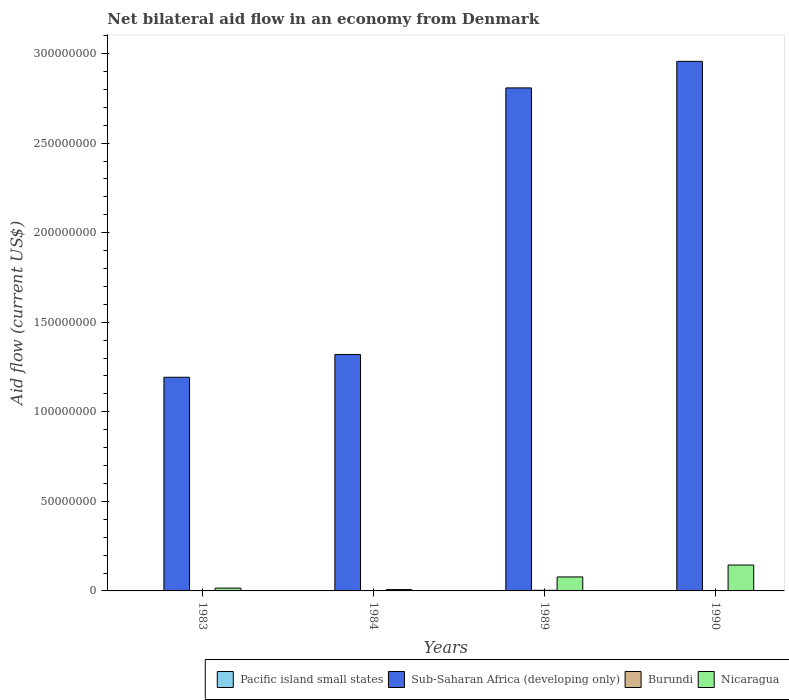How many different coloured bars are there?
Give a very brief answer. 4. How many groups of bars are there?
Offer a very short reply. 4. Are the number of bars per tick equal to the number of legend labels?
Ensure brevity in your answer.  Yes. How many bars are there on the 2nd tick from the left?
Make the answer very short. 4. How many bars are there on the 2nd tick from the right?
Provide a succinct answer. 4. In how many cases, is the number of bars for a given year not equal to the number of legend labels?
Your answer should be very brief. 0. What is the net bilateral aid flow in Pacific island small states in 1983?
Provide a short and direct response. 1.30e+05. Across all years, what is the maximum net bilateral aid flow in Burundi?
Provide a succinct answer. 3.40e+05. Across all years, what is the minimum net bilateral aid flow in Nicaragua?
Provide a short and direct response. 7.50e+05. In which year was the net bilateral aid flow in Pacific island small states maximum?
Your answer should be very brief. 1983. What is the total net bilateral aid flow in Burundi in the graph?
Offer a terse response. 4.80e+05. What is the difference between the net bilateral aid flow in Burundi in 1990 and the net bilateral aid flow in Nicaragua in 1984?
Make the answer very short. -7.20e+05. What is the average net bilateral aid flow in Pacific island small states per year?
Provide a short and direct response. 6.50e+04. In the year 1990, what is the difference between the net bilateral aid flow in Burundi and net bilateral aid flow in Nicaragua?
Offer a terse response. -1.44e+07. What is the ratio of the net bilateral aid flow in Burundi in 1983 to that in 1989?
Keep it short and to the point. 0.18. Is the net bilateral aid flow in Burundi in 1989 less than that in 1990?
Give a very brief answer. No. What is the difference between the highest and the second highest net bilateral aid flow in Sub-Saharan Africa (developing only)?
Your answer should be very brief. 1.48e+07. Is the sum of the net bilateral aid flow in Nicaragua in 1983 and 1989 greater than the maximum net bilateral aid flow in Pacific island small states across all years?
Ensure brevity in your answer.  Yes. What does the 4th bar from the left in 1983 represents?
Your answer should be compact. Nicaragua. What does the 2nd bar from the right in 1990 represents?
Your response must be concise. Burundi. Is it the case that in every year, the sum of the net bilateral aid flow in Burundi and net bilateral aid flow in Pacific island small states is greater than the net bilateral aid flow in Sub-Saharan Africa (developing only)?
Make the answer very short. No. Are all the bars in the graph horizontal?
Offer a very short reply. No. Does the graph contain any zero values?
Make the answer very short. No. Where does the legend appear in the graph?
Your response must be concise. Bottom right. How many legend labels are there?
Keep it short and to the point. 4. How are the legend labels stacked?
Provide a short and direct response. Horizontal. What is the title of the graph?
Ensure brevity in your answer.  Net bilateral aid flow in an economy from Denmark. What is the label or title of the X-axis?
Make the answer very short. Years. What is the Aid flow (current US$) in Sub-Saharan Africa (developing only) in 1983?
Your answer should be compact. 1.19e+08. What is the Aid flow (current US$) of Nicaragua in 1983?
Your answer should be very brief. 1.57e+06. What is the Aid flow (current US$) in Sub-Saharan Africa (developing only) in 1984?
Ensure brevity in your answer.  1.32e+08. What is the Aid flow (current US$) in Nicaragua in 1984?
Provide a short and direct response. 7.50e+05. What is the Aid flow (current US$) of Sub-Saharan Africa (developing only) in 1989?
Ensure brevity in your answer.  2.81e+08. What is the Aid flow (current US$) of Burundi in 1989?
Offer a terse response. 3.40e+05. What is the Aid flow (current US$) of Nicaragua in 1989?
Offer a terse response. 7.81e+06. What is the Aid flow (current US$) in Pacific island small states in 1990?
Offer a very short reply. 4.00e+04. What is the Aid flow (current US$) of Sub-Saharan Africa (developing only) in 1990?
Provide a succinct answer. 2.96e+08. What is the Aid flow (current US$) in Burundi in 1990?
Provide a short and direct response. 3.00e+04. What is the Aid flow (current US$) in Nicaragua in 1990?
Offer a very short reply. 1.45e+07. Across all years, what is the maximum Aid flow (current US$) in Sub-Saharan Africa (developing only)?
Keep it short and to the point. 2.96e+08. Across all years, what is the maximum Aid flow (current US$) of Nicaragua?
Your response must be concise. 1.45e+07. Across all years, what is the minimum Aid flow (current US$) in Sub-Saharan Africa (developing only)?
Your answer should be very brief. 1.19e+08. Across all years, what is the minimum Aid flow (current US$) in Burundi?
Your response must be concise. 3.00e+04. Across all years, what is the minimum Aid flow (current US$) in Nicaragua?
Make the answer very short. 7.50e+05. What is the total Aid flow (current US$) in Pacific island small states in the graph?
Your response must be concise. 2.60e+05. What is the total Aid flow (current US$) of Sub-Saharan Africa (developing only) in the graph?
Provide a succinct answer. 8.28e+08. What is the total Aid flow (current US$) of Nicaragua in the graph?
Offer a very short reply. 2.46e+07. What is the difference between the Aid flow (current US$) of Sub-Saharan Africa (developing only) in 1983 and that in 1984?
Make the answer very short. -1.27e+07. What is the difference between the Aid flow (current US$) in Burundi in 1983 and that in 1984?
Keep it short and to the point. 10000. What is the difference between the Aid flow (current US$) of Nicaragua in 1983 and that in 1984?
Ensure brevity in your answer.  8.20e+05. What is the difference between the Aid flow (current US$) of Sub-Saharan Africa (developing only) in 1983 and that in 1989?
Your response must be concise. -1.62e+08. What is the difference between the Aid flow (current US$) of Burundi in 1983 and that in 1989?
Offer a very short reply. -2.80e+05. What is the difference between the Aid flow (current US$) of Nicaragua in 1983 and that in 1989?
Offer a very short reply. -6.24e+06. What is the difference between the Aid flow (current US$) in Pacific island small states in 1983 and that in 1990?
Ensure brevity in your answer.  9.00e+04. What is the difference between the Aid flow (current US$) of Sub-Saharan Africa (developing only) in 1983 and that in 1990?
Your response must be concise. -1.76e+08. What is the difference between the Aid flow (current US$) of Nicaragua in 1983 and that in 1990?
Make the answer very short. -1.29e+07. What is the difference between the Aid flow (current US$) in Pacific island small states in 1984 and that in 1989?
Make the answer very short. 10000. What is the difference between the Aid flow (current US$) of Sub-Saharan Africa (developing only) in 1984 and that in 1989?
Offer a very short reply. -1.49e+08. What is the difference between the Aid flow (current US$) in Nicaragua in 1984 and that in 1989?
Provide a succinct answer. -7.06e+06. What is the difference between the Aid flow (current US$) of Pacific island small states in 1984 and that in 1990?
Make the answer very short. 10000. What is the difference between the Aid flow (current US$) of Sub-Saharan Africa (developing only) in 1984 and that in 1990?
Your response must be concise. -1.64e+08. What is the difference between the Aid flow (current US$) in Nicaragua in 1984 and that in 1990?
Ensure brevity in your answer.  -1.37e+07. What is the difference between the Aid flow (current US$) of Sub-Saharan Africa (developing only) in 1989 and that in 1990?
Your answer should be very brief. -1.48e+07. What is the difference between the Aid flow (current US$) in Burundi in 1989 and that in 1990?
Offer a terse response. 3.10e+05. What is the difference between the Aid flow (current US$) of Nicaragua in 1989 and that in 1990?
Ensure brevity in your answer.  -6.65e+06. What is the difference between the Aid flow (current US$) in Pacific island small states in 1983 and the Aid flow (current US$) in Sub-Saharan Africa (developing only) in 1984?
Keep it short and to the point. -1.32e+08. What is the difference between the Aid flow (current US$) of Pacific island small states in 1983 and the Aid flow (current US$) of Nicaragua in 1984?
Ensure brevity in your answer.  -6.20e+05. What is the difference between the Aid flow (current US$) in Sub-Saharan Africa (developing only) in 1983 and the Aid flow (current US$) in Burundi in 1984?
Your answer should be compact. 1.19e+08. What is the difference between the Aid flow (current US$) of Sub-Saharan Africa (developing only) in 1983 and the Aid flow (current US$) of Nicaragua in 1984?
Give a very brief answer. 1.19e+08. What is the difference between the Aid flow (current US$) in Burundi in 1983 and the Aid flow (current US$) in Nicaragua in 1984?
Ensure brevity in your answer.  -6.90e+05. What is the difference between the Aid flow (current US$) in Pacific island small states in 1983 and the Aid flow (current US$) in Sub-Saharan Africa (developing only) in 1989?
Your answer should be very brief. -2.81e+08. What is the difference between the Aid flow (current US$) of Pacific island small states in 1983 and the Aid flow (current US$) of Burundi in 1989?
Your response must be concise. -2.10e+05. What is the difference between the Aid flow (current US$) of Pacific island small states in 1983 and the Aid flow (current US$) of Nicaragua in 1989?
Ensure brevity in your answer.  -7.68e+06. What is the difference between the Aid flow (current US$) of Sub-Saharan Africa (developing only) in 1983 and the Aid flow (current US$) of Burundi in 1989?
Your answer should be very brief. 1.19e+08. What is the difference between the Aid flow (current US$) in Sub-Saharan Africa (developing only) in 1983 and the Aid flow (current US$) in Nicaragua in 1989?
Offer a terse response. 1.11e+08. What is the difference between the Aid flow (current US$) of Burundi in 1983 and the Aid flow (current US$) of Nicaragua in 1989?
Give a very brief answer. -7.75e+06. What is the difference between the Aid flow (current US$) of Pacific island small states in 1983 and the Aid flow (current US$) of Sub-Saharan Africa (developing only) in 1990?
Your response must be concise. -2.96e+08. What is the difference between the Aid flow (current US$) of Pacific island small states in 1983 and the Aid flow (current US$) of Burundi in 1990?
Give a very brief answer. 1.00e+05. What is the difference between the Aid flow (current US$) in Pacific island small states in 1983 and the Aid flow (current US$) in Nicaragua in 1990?
Offer a very short reply. -1.43e+07. What is the difference between the Aid flow (current US$) in Sub-Saharan Africa (developing only) in 1983 and the Aid flow (current US$) in Burundi in 1990?
Your answer should be compact. 1.19e+08. What is the difference between the Aid flow (current US$) of Sub-Saharan Africa (developing only) in 1983 and the Aid flow (current US$) of Nicaragua in 1990?
Provide a succinct answer. 1.05e+08. What is the difference between the Aid flow (current US$) in Burundi in 1983 and the Aid flow (current US$) in Nicaragua in 1990?
Provide a succinct answer. -1.44e+07. What is the difference between the Aid flow (current US$) in Pacific island small states in 1984 and the Aid flow (current US$) in Sub-Saharan Africa (developing only) in 1989?
Your answer should be very brief. -2.81e+08. What is the difference between the Aid flow (current US$) of Pacific island small states in 1984 and the Aid flow (current US$) of Burundi in 1989?
Ensure brevity in your answer.  -2.90e+05. What is the difference between the Aid flow (current US$) of Pacific island small states in 1984 and the Aid flow (current US$) of Nicaragua in 1989?
Your response must be concise. -7.76e+06. What is the difference between the Aid flow (current US$) of Sub-Saharan Africa (developing only) in 1984 and the Aid flow (current US$) of Burundi in 1989?
Ensure brevity in your answer.  1.32e+08. What is the difference between the Aid flow (current US$) of Sub-Saharan Africa (developing only) in 1984 and the Aid flow (current US$) of Nicaragua in 1989?
Give a very brief answer. 1.24e+08. What is the difference between the Aid flow (current US$) of Burundi in 1984 and the Aid flow (current US$) of Nicaragua in 1989?
Offer a very short reply. -7.76e+06. What is the difference between the Aid flow (current US$) of Pacific island small states in 1984 and the Aid flow (current US$) of Sub-Saharan Africa (developing only) in 1990?
Your response must be concise. -2.96e+08. What is the difference between the Aid flow (current US$) in Pacific island small states in 1984 and the Aid flow (current US$) in Burundi in 1990?
Ensure brevity in your answer.  2.00e+04. What is the difference between the Aid flow (current US$) in Pacific island small states in 1984 and the Aid flow (current US$) in Nicaragua in 1990?
Make the answer very short. -1.44e+07. What is the difference between the Aid flow (current US$) of Sub-Saharan Africa (developing only) in 1984 and the Aid flow (current US$) of Burundi in 1990?
Offer a terse response. 1.32e+08. What is the difference between the Aid flow (current US$) in Sub-Saharan Africa (developing only) in 1984 and the Aid flow (current US$) in Nicaragua in 1990?
Your answer should be very brief. 1.18e+08. What is the difference between the Aid flow (current US$) of Burundi in 1984 and the Aid flow (current US$) of Nicaragua in 1990?
Offer a terse response. -1.44e+07. What is the difference between the Aid flow (current US$) of Pacific island small states in 1989 and the Aid flow (current US$) of Sub-Saharan Africa (developing only) in 1990?
Give a very brief answer. -2.96e+08. What is the difference between the Aid flow (current US$) of Pacific island small states in 1989 and the Aid flow (current US$) of Burundi in 1990?
Offer a terse response. 10000. What is the difference between the Aid flow (current US$) in Pacific island small states in 1989 and the Aid flow (current US$) in Nicaragua in 1990?
Offer a very short reply. -1.44e+07. What is the difference between the Aid flow (current US$) of Sub-Saharan Africa (developing only) in 1989 and the Aid flow (current US$) of Burundi in 1990?
Keep it short and to the point. 2.81e+08. What is the difference between the Aid flow (current US$) of Sub-Saharan Africa (developing only) in 1989 and the Aid flow (current US$) of Nicaragua in 1990?
Offer a terse response. 2.66e+08. What is the difference between the Aid flow (current US$) in Burundi in 1989 and the Aid flow (current US$) in Nicaragua in 1990?
Keep it short and to the point. -1.41e+07. What is the average Aid flow (current US$) in Pacific island small states per year?
Provide a succinct answer. 6.50e+04. What is the average Aid flow (current US$) in Sub-Saharan Africa (developing only) per year?
Your response must be concise. 2.07e+08. What is the average Aid flow (current US$) of Burundi per year?
Ensure brevity in your answer.  1.20e+05. What is the average Aid flow (current US$) in Nicaragua per year?
Offer a terse response. 6.15e+06. In the year 1983, what is the difference between the Aid flow (current US$) in Pacific island small states and Aid flow (current US$) in Sub-Saharan Africa (developing only)?
Give a very brief answer. -1.19e+08. In the year 1983, what is the difference between the Aid flow (current US$) of Pacific island small states and Aid flow (current US$) of Burundi?
Provide a succinct answer. 7.00e+04. In the year 1983, what is the difference between the Aid flow (current US$) of Pacific island small states and Aid flow (current US$) of Nicaragua?
Ensure brevity in your answer.  -1.44e+06. In the year 1983, what is the difference between the Aid flow (current US$) of Sub-Saharan Africa (developing only) and Aid flow (current US$) of Burundi?
Ensure brevity in your answer.  1.19e+08. In the year 1983, what is the difference between the Aid flow (current US$) of Sub-Saharan Africa (developing only) and Aid flow (current US$) of Nicaragua?
Offer a terse response. 1.18e+08. In the year 1983, what is the difference between the Aid flow (current US$) of Burundi and Aid flow (current US$) of Nicaragua?
Your response must be concise. -1.51e+06. In the year 1984, what is the difference between the Aid flow (current US$) of Pacific island small states and Aid flow (current US$) of Sub-Saharan Africa (developing only)?
Your answer should be very brief. -1.32e+08. In the year 1984, what is the difference between the Aid flow (current US$) in Pacific island small states and Aid flow (current US$) in Nicaragua?
Keep it short and to the point. -7.00e+05. In the year 1984, what is the difference between the Aid flow (current US$) of Sub-Saharan Africa (developing only) and Aid flow (current US$) of Burundi?
Your answer should be very brief. 1.32e+08. In the year 1984, what is the difference between the Aid flow (current US$) in Sub-Saharan Africa (developing only) and Aid flow (current US$) in Nicaragua?
Provide a short and direct response. 1.31e+08. In the year 1984, what is the difference between the Aid flow (current US$) of Burundi and Aid flow (current US$) of Nicaragua?
Your answer should be very brief. -7.00e+05. In the year 1989, what is the difference between the Aid flow (current US$) of Pacific island small states and Aid flow (current US$) of Sub-Saharan Africa (developing only)?
Make the answer very short. -2.81e+08. In the year 1989, what is the difference between the Aid flow (current US$) in Pacific island small states and Aid flow (current US$) in Burundi?
Offer a very short reply. -3.00e+05. In the year 1989, what is the difference between the Aid flow (current US$) of Pacific island small states and Aid flow (current US$) of Nicaragua?
Provide a short and direct response. -7.77e+06. In the year 1989, what is the difference between the Aid flow (current US$) of Sub-Saharan Africa (developing only) and Aid flow (current US$) of Burundi?
Your answer should be very brief. 2.81e+08. In the year 1989, what is the difference between the Aid flow (current US$) in Sub-Saharan Africa (developing only) and Aid flow (current US$) in Nicaragua?
Your answer should be very brief. 2.73e+08. In the year 1989, what is the difference between the Aid flow (current US$) in Burundi and Aid flow (current US$) in Nicaragua?
Keep it short and to the point. -7.47e+06. In the year 1990, what is the difference between the Aid flow (current US$) of Pacific island small states and Aid flow (current US$) of Sub-Saharan Africa (developing only)?
Your response must be concise. -2.96e+08. In the year 1990, what is the difference between the Aid flow (current US$) in Pacific island small states and Aid flow (current US$) in Nicaragua?
Make the answer very short. -1.44e+07. In the year 1990, what is the difference between the Aid flow (current US$) of Sub-Saharan Africa (developing only) and Aid flow (current US$) of Burundi?
Offer a terse response. 2.96e+08. In the year 1990, what is the difference between the Aid flow (current US$) in Sub-Saharan Africa (developing only) and Aid flow (current US$) in Nicaragua?
Ensure brevity in your answer.  2.81e+08. In the year 1990, what is the difference between the Aid flow (current US$) of Burundi and Aid flow (current US$) of Nicaragua?
Give a very brief answer. -1.44e+07. What is the ratio of the Aid flow (current US$) in Sub-Saharan Africa (developing only) in 1983 to that in 1984?
Provide a succinct answer. 0.9. What is the ratio of the Aid flow (current US$) in Nicaragua in 1983 to that in 1984?
Your answer should be compact. 2.09. What is the ratio of the Aid flow (current US$) of Pacific island small states in 1983 to that in 1989?
Your answer should be very brief. 3.25. What is the ratio of the Aid flow (current US$) in Sub-Saharan Africa (developing only) in 1983 to that in 1989?
Ensure brevity in your answer.  0.42. What is the ratio of the Aid flow (current US$) of Burundi in 1983 to that in 1989?
Your answer should be compact. 0.18. What is the ratio of the Aid flow (current US$) in Nicaragua in 1983 to that in 1989?
Make the answer very short. 0.2. What is the ratio of the Aid flow (current US$) in Sub-Saharan Africa (developing only) in 1983 to that in 1990?
Your answer should be very brief. 0.4. What is the ratio of the Aid flow (current US$) in Burundi in 1983 to that in 1990?
Offer a very short reply. 2. What is the ratio of the Aid flow (current US$) of Nicaragua in 1983 to that in 1990?
Your answer should be compact. 0.11. What is the ratio of the Aid flow (current US$) in Pacific island small states in 1984 to that in 1989?
Ensure brevity in your answer.  1.25. What is the ratio of the Aid flow (current US$) of Sub-Saharan Africa (developing only) in 1984 to that in 1989?
Give a very brief answer. 0.47. What is the ratio of the Aid flow (current US$) of Burundi in 1984 to that in 1989?
Your answer should be compact. 0.15. What is the ratio of the Aid flow (current US$) of Nicaragua in 1984 to that in 1989?
Make the answer very short. 0.1. What is the ratio of the Aid flow (current US$) in Sub-Saharan Africa (developing only) in 1984 to that in 1990?
Provide a succinct answer. 0.45. What is the ratio of the Aid flow (current US$) in Burundi in 1984 to that in 1990?
Offer a very short reply. 1.67. What is the ratio of the Aid flow (current US$) in Nicaragua in 1984 to that in 1990?
Your response must be concise. 0.05. What is the ratio of the Aid flow (current US$) of Sub-Saharan Africa (developing only) in 1989 to that in 1990?
Your response must be concise. 0.95. What is the ratio of the Aid flow (current US$) in Burundi in 1989 to that in 1990?
Your response must be concise. 11.33. What is the ratio of the Aid flow (current US$) of Nicaragua in 1989 to that in 1990?
Your response must be concise. 0.54. What is the difference between the highest and the second highest Aid flow (current US$) of Sub-Saharan Africa (developing only)?
Provide a succinct answer. 1.48e+07. What is the difference between the highest and the second highest Aid flow (current US$) of Nicaragua?
Offer a very short reply. 6.65e+06. What is the difference between the highest and the lowest Aid flow (current US$) of Pacific island small states?
Your response must be concise. 9.00e+04. What is the difference between the highest and the lowest Aid flow (current US$) of Sub-Saharan Africa (developing only)?
Offer a terse response. 1.76e+08. What is the difference between the highest and the lowest Aid flow (current US$) of Burundi?
Your response must be concise. 3.10e+05. What is the difference between the highest and the lowest Aid flow (current US$) in Nicaragua?
Your response must be concise. 1.37e+07. 